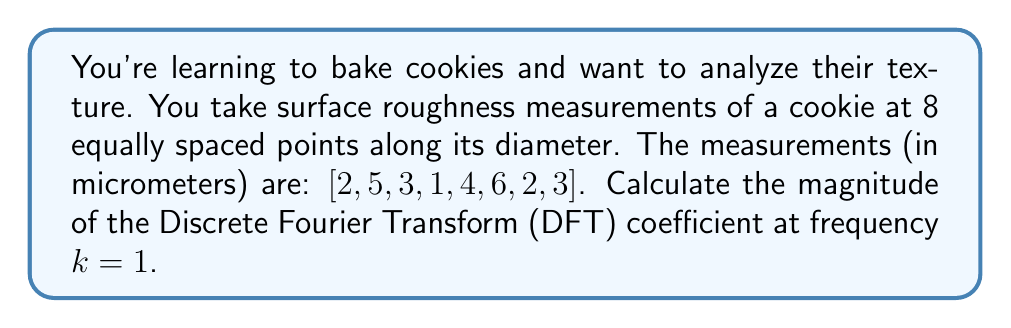Provide a solution to this math problem. To solve this problem, we'll follow these steps:

1) The Discrete Fourier Transform (DFT) for a sequence x[n] of length N is given by:

   $$X[k] = \sum_{n=0}^{N-1} x[n] e^{-i2\pi kn/N}$$

   where k = 0, 1, ..., N-1

2) In this case, N = 8 and we need to calculate |X[1]|.

3) Let's substitute k = 1 into the formula:

   $$X[1] = \sum_{n=0}^{7} x[n] e^{-i2\pi n/8}$$

4) Now, let's calculate $e^{-i2\pi n/8}$ for n = 0 to 7:
   
   n = 0: $e^{0} = 1$
   n = 1: $e^{-i\pi/4} = \frac{\sqrt{2}}{2} - i\frac{\sqrt{2}}{2}$
   n = 2: $e^{-i\pi/2} = -i$
   n = 3: $e^{-i3\pi/4} = -\frac{\sqrt{2}}{2} - i\frac{\sqrt{2}}{2}$
   n = 4: $e^{-i\pi} = -1$
   n = 5: $e^{-i5\pi/4} = -\frac{\sqrt{2}}{2} + i\frac{\sqrt{2}}{2}$
   n = 6: $e^{-i3\pi/2} = i$
   n = 7: $e^{-i7\pi/4} = \frac{\sqrt{2}}{2} + i\frac{\sqrt{2}}{2}$

5) Now, let's multiply each x[n] by its corresponding complex exponential and sum:

   $$X[1] = 2 + 5(\frac{\sqrt{2}}{2} - i\frac{\sqrt{2}}{2}) + 3(-i) + 1(-\frac{\sqrt{2}}{2} - i\frac{\sqrt{2}}{2}) + 4(-1) + 6(-\frac{\sqrt{2}}{2} + i\frac{\sqrt{2}}{2}) + 2i + 3(\frac{\sqrt{2}}{2} + i\frac{\sqrt{2}}{2})$$

6) Simplify the real and imaginary parts:

   Real part: $2 + 5\frac{\sqrt{2}}{2} - \frac{\sqrt{2}}{2} - 4 - 6\frac{\sqrt{2}}{2} + 3\frac{\sqrt{2}}{2} = -2 + \frac{\sqrt{2}}{2}$

   Imaginary part: $-5\frac{\sqrt{2}}{2} - 3 - \frac{\sqrt{2}}{2} + 6\frac{\sqrt{2}}{2} + 2 + 3\frac{\sqrt{2}}{2} = -1 + 3\frac{\sqrt{2}}{2}$

7) Therefore, $X[1] = (-2 + \frac{\sqrt{2}}{2}) + i(-1 + 3\frac{\sqrt{2}}{2})$

8) The magnitude of X[1] is given by $|X[1]| = \sqrt{(\text{Real part})^2 + (\text{Imaginary part})^2}$

   $$|X[1]| = \sqrt{(-2 + \frac{\sqrt{2}}{2})^2 + (-1 + 3\frac{\sqrt{2}}{2})^2}$$

9) Simplify under the square root:

   $$|X[1]| = \sqrt{4 - 2\sqrt{2} + \frac{1}{2} + 1 - 3\sqrt{2} + \frac{9}{2}} = \sqrt{\frac{11}{2} - 5\sqrt{2}}$$
Answer: $|X[1]| = \sqrt{\frac{11}{2} - 5\sqrt{2}}$ micrometers 